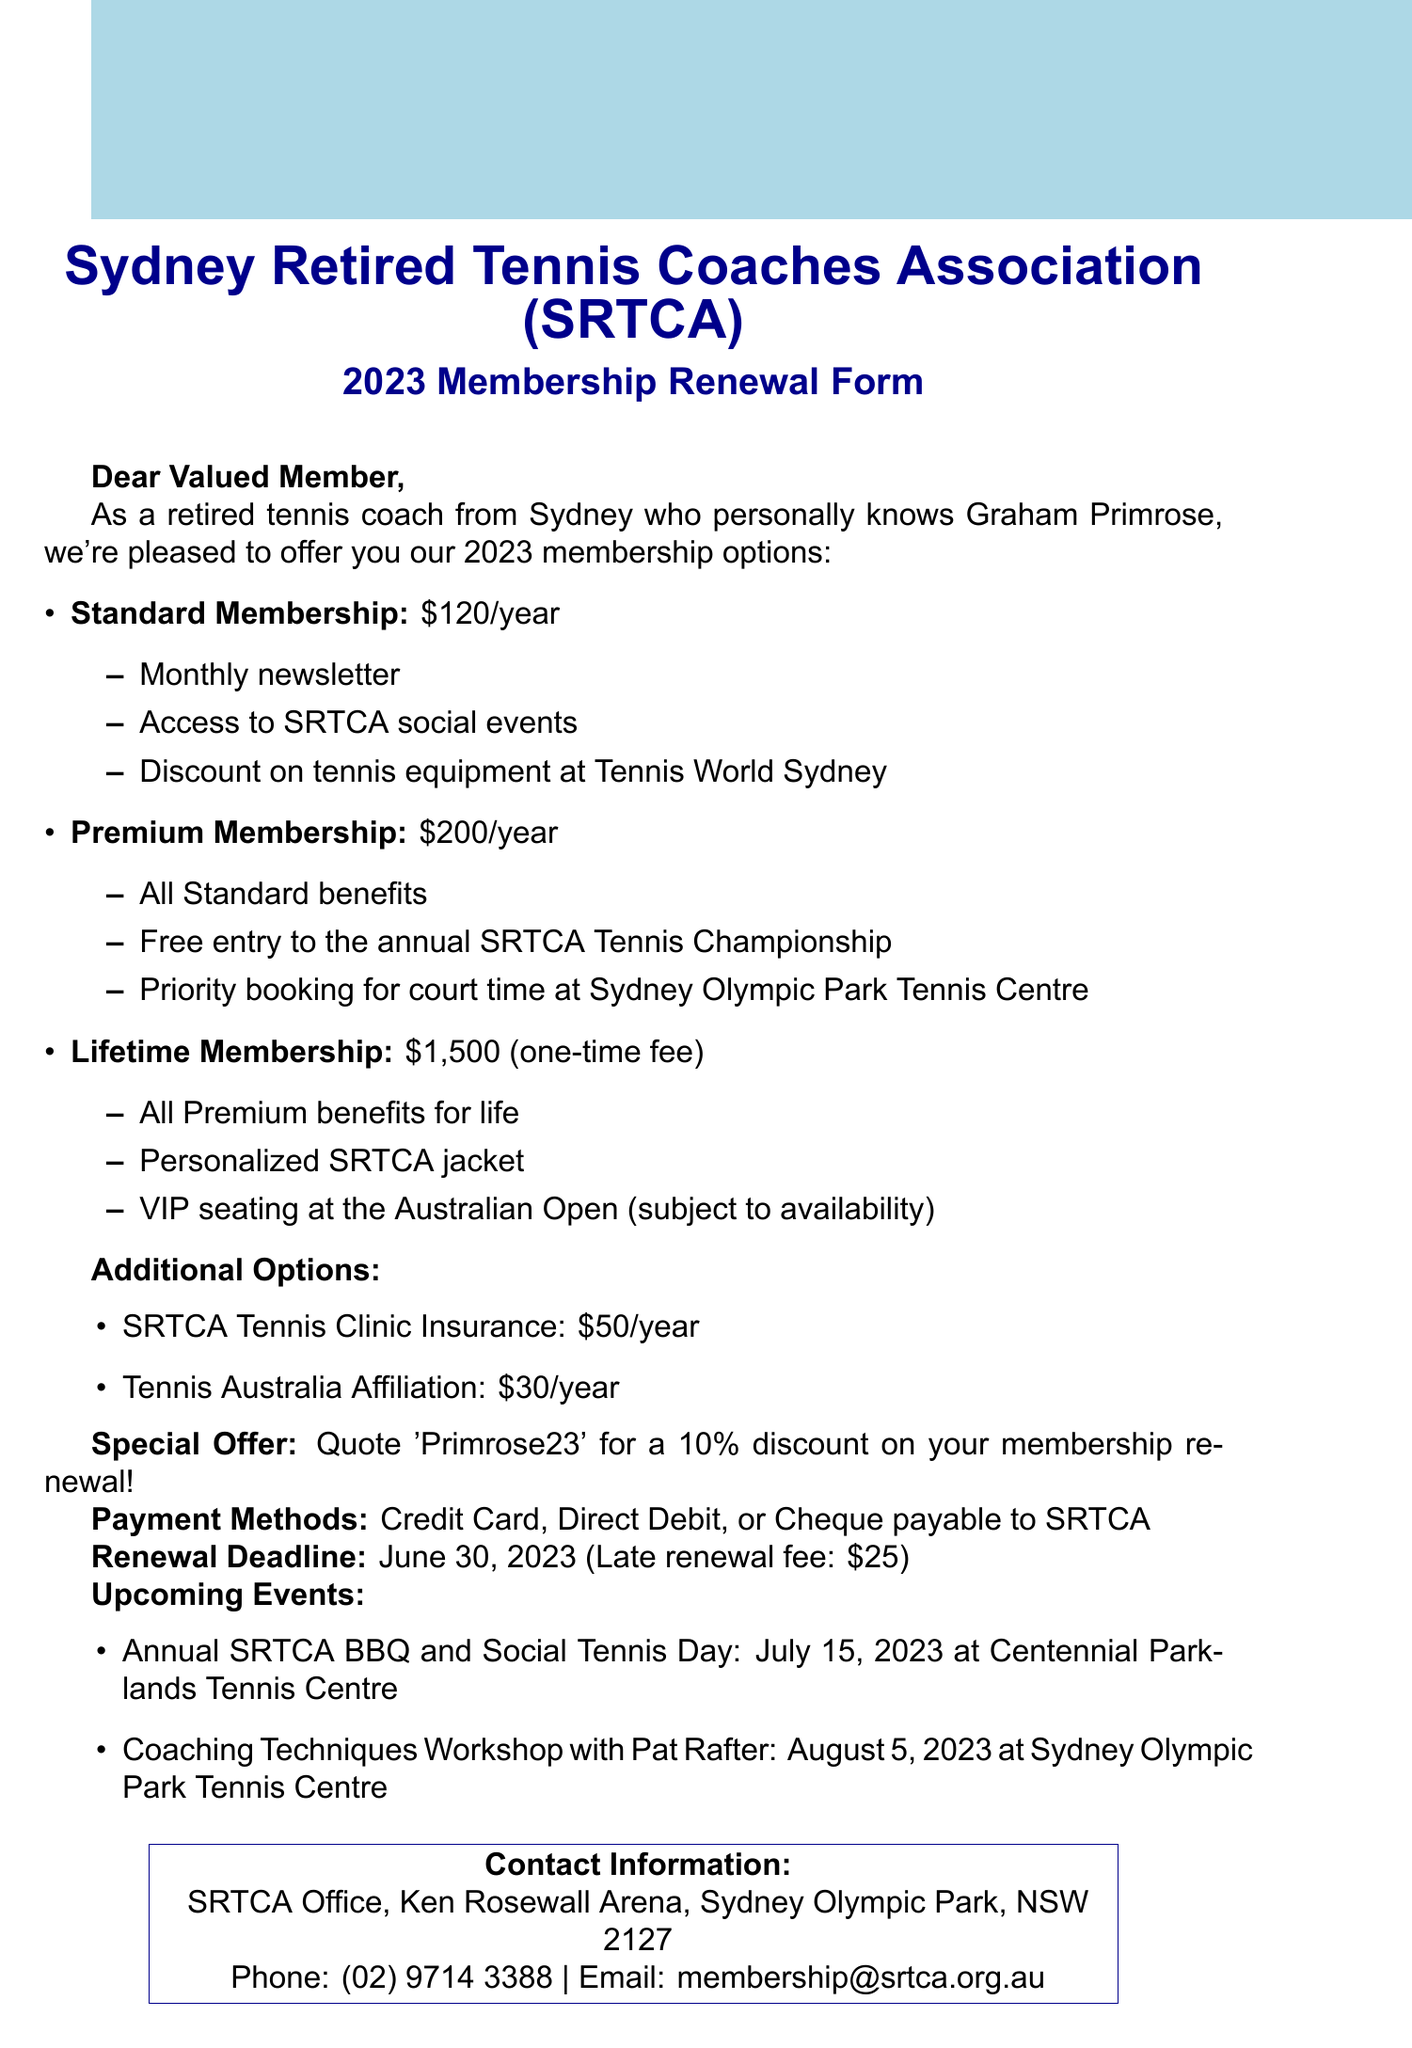what is the annual fee for Standard membership? The annual fee for Standard membership is clearly listed in the benefits section of the document.
Answer: 120 what is the one-time fee for Lifetime membership? The document specifies the one-time fee for Lifetime membership, which is detailed in the membership options.
Answer: 1500 what is the renewal deadline for membership? The renewal deadline is mentioned explicitly in the document under the relevant section.
Answer: June 30, 2023 what are the benefits of Premium membership? The document lists the benefits of Premium membership in the itemized section under membership types.
Answer: All Standard benefits, Free entry to the annual SRTCA Tennis Championship, Priority booking for court time at Sydney Olympic Park Tennis Centre what is the late renewal fee? The document states the late renewal fee, which is mentioned in the renewal section.
Answer: 25 which special offer can members quote for a discount? The special offer that members can use for a discount is outlined in the special note of the document.
Answer: Primrose23 how much is the annual fee for SRTCA Tennis Clinic Insurance? The document provides the annual fee for this additional option in the list of fees.
Answer: 50 where is the SRTCA office located? The document specifies the location of the SRTCA office in the contact information section.
Answer: SRTCA Office, Ken Rosewall Arena, Sydney Olympic Park, NSW 2127 when is the Annual SRTCA BBQ and Social Tennis Day? The date for this upcoming event is listed in the events section of the document.
Answer: July 15, 2023 